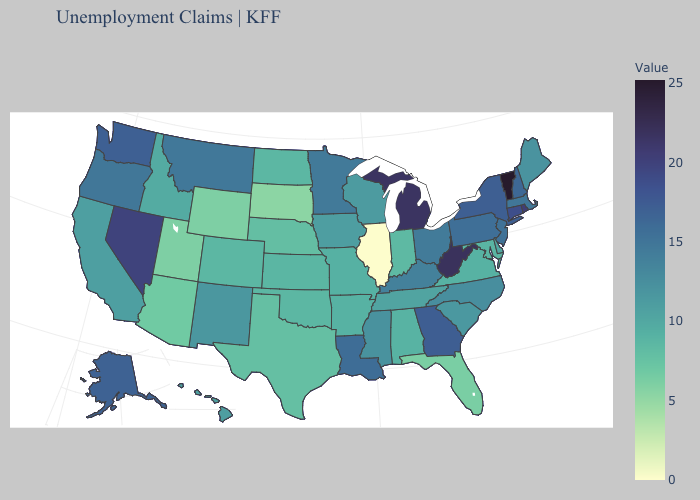Does Wyoming have the lowest value in the West?
Keep it brief. Yes. Among the states that border Florida , does Georgia have the highest value?
Answer briefly. Yes. Is the legend a continuous bar?
Answer briefly. Yes. Does Alabama have a lower value than Ohio?
Keep it brief. Yes. Which states hav the highest value in the Northeast?
Quick response, please. Vermont. Does Tennessee have a lower value than Utah?
Keep it brief. No. Is the legend a continuous bar?
Keep it brief. Yes. Does Montana have a higher value than West Virginia?
Quick response, please. No. 